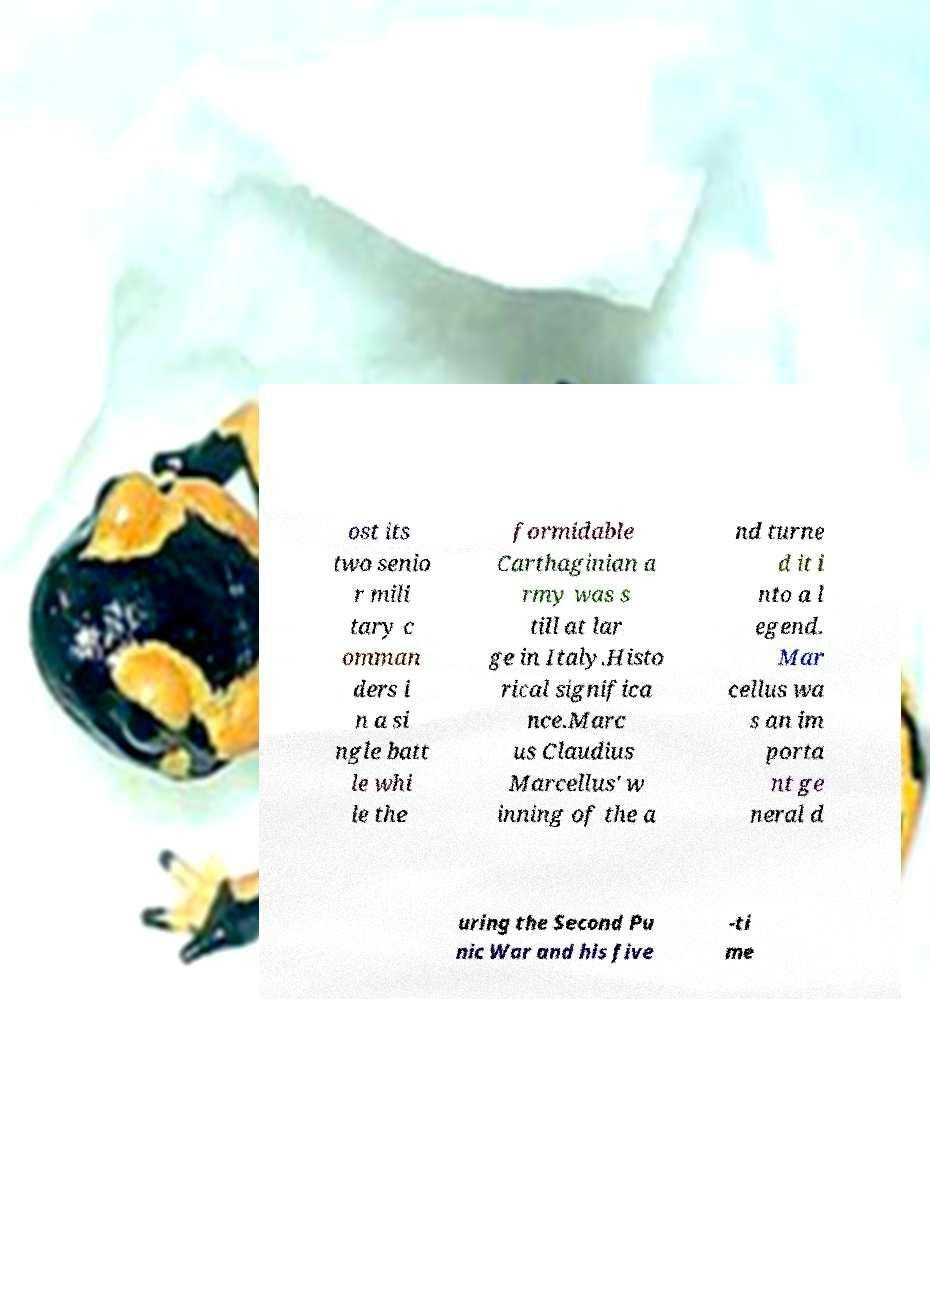I need the written content from this picture converted into text. Can you do that? ost its two senio r mili tary c omman ders i n a si ngle batt le whi le the formidable Carthaginian a rmy was s till at lar ge in Italy.Histo rical significa nce.Marc us Claudius Marcellus' w inning of the a nd turne d it i nto a l egend. Mar cellus wa s an im porta nt ge neral d uring the Second Pu nic War and his five -ti me 